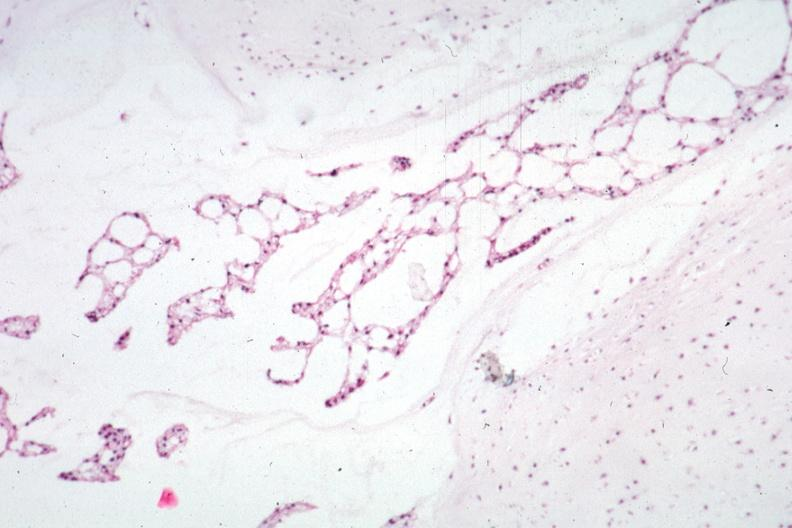what does this image show?
Answer the question using a single word or phrase. Micro low mag h&e would have to get protocol to determine where section was taken 